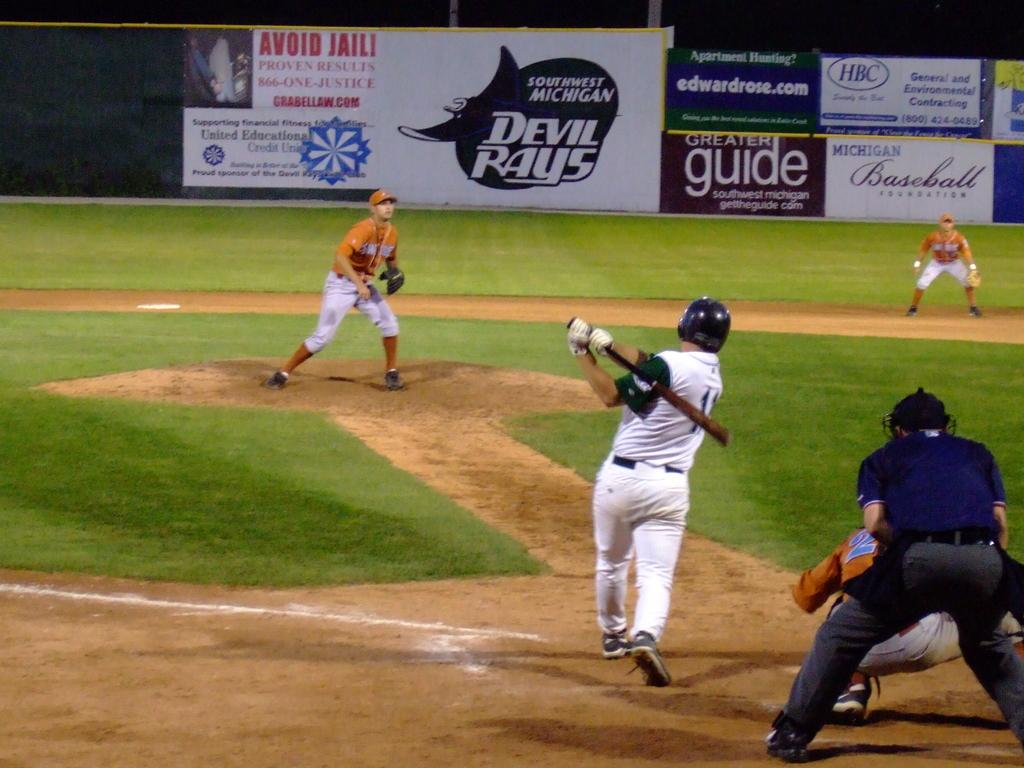<image>
Present a compact description of the photo's key features. A man hits a baseball and there are several advertisements in the background, including one for Devil Rays. 